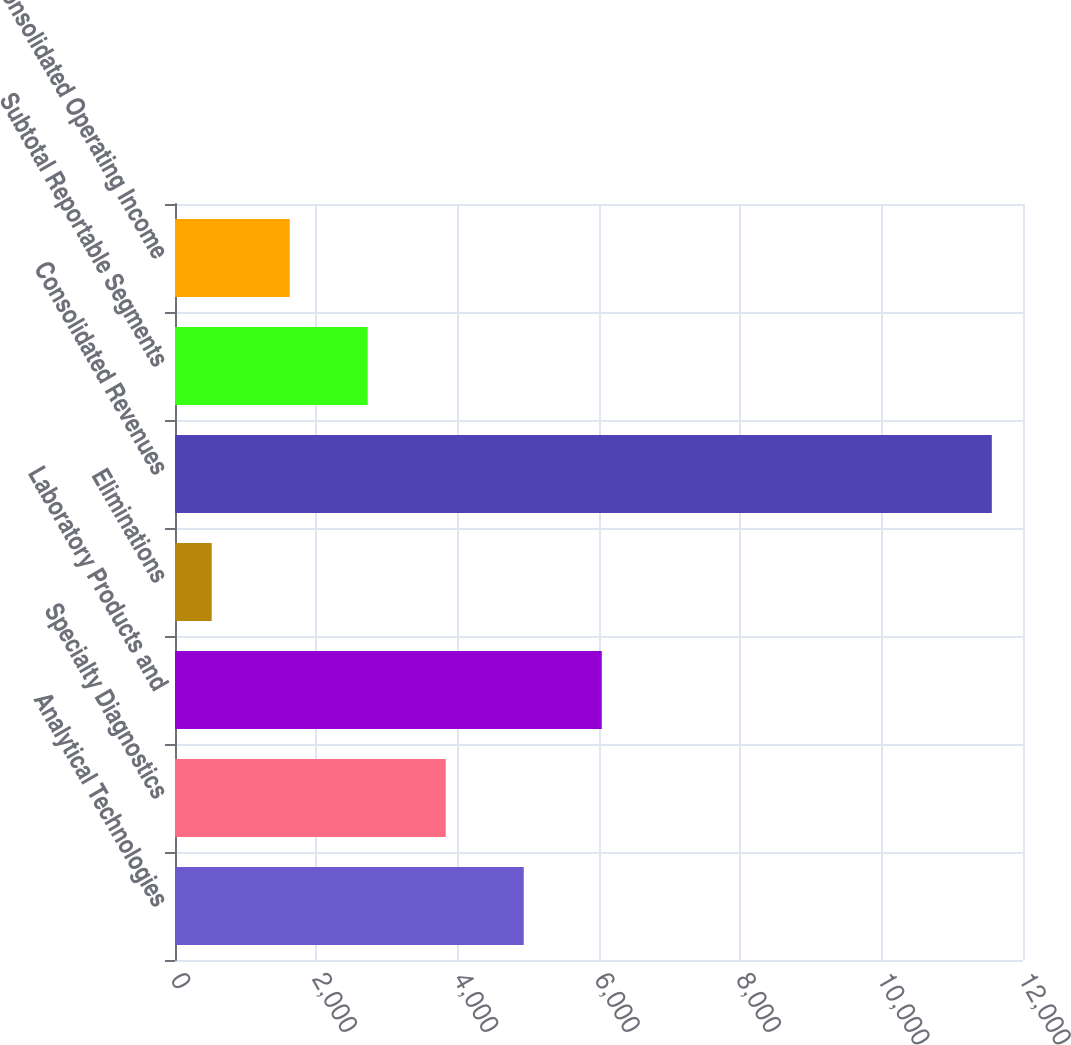Convert chart. <chart><loc_0><loc_0><loc_500><loc_500><bar_chart><fcel>Analytical Technologies<fcel>Specialty Diagnostics<fcel>Laboratory Products and<fcel>Eliminations<fcel>Consolidated Revenues<fcel>Subtotal Reportable Segments<fcel>Consolidated Operating Income<nl><fcel>4935.16<fcel>3831.22<fcel>6039.1<fcel>519.4<fcel>11558.8<fcel>2727.28<fcel>1623.34<nl></chart> 